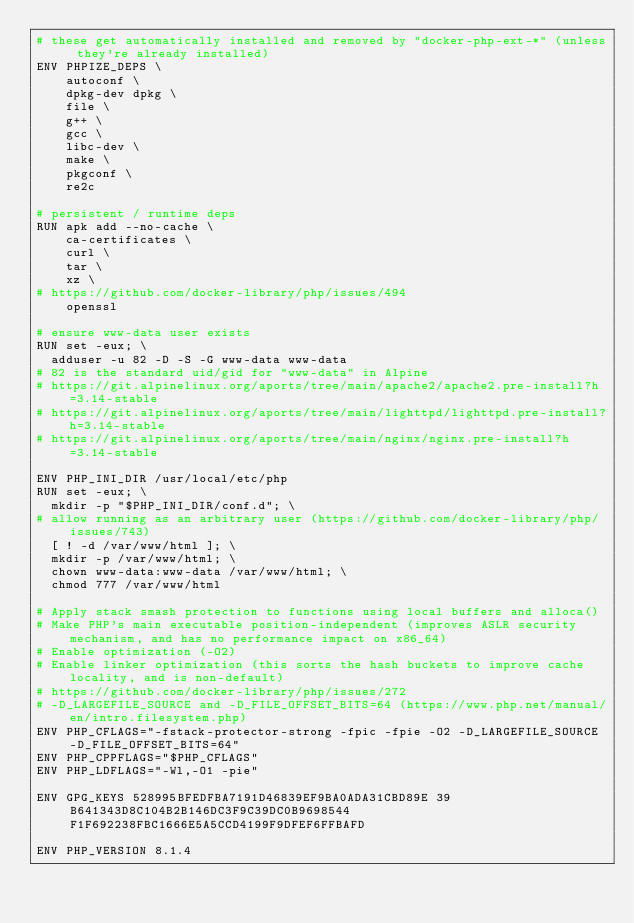Convert code to text. <code><loc_0><loc_0><loc_500><loc_500><_Dockerfile_># these get automatically installed and removed by "docker-php-ext-*" (unless they're already installed)
ENV PHPIZE_DEPS \
		autoconf \
		dpkg-dev dpkg \
		file \
		g++ \
		gcc \
		libc-dev \
		make \
		pkgconf \
		re2c

# persistent / runtime deps
RUN apk add --no-cache \
		ca-certificates \
		curl \
		tar \
		xz \
# https://github.com/docker-library/php/issues/494
		openssl

# ensure www-data user exists
RUN set -eux; \
	adduser -u 82 -D -S -G www-data www-data
# 82 is the standard uid/gid for "www-data" in Alpine
# https://git.alpinelinux.org/aports/tree/main/apache2/apache2.pre-install?h=3.14-stable
# https://git.alpinelinux.org/aports/tree/main/lighttpd/lighttpd.pre-install?h=3.14-stable
# https://git.alpinelinux.org/aports/tree/main/nginx/nginx.pre-install?h=3.14-stable

ENV PHP_INI_DIR /usr/local/etc/php
RUN set -eux; \
	mkdir -p "$PHP_INI_DIR/conf.d"; \
# allow running as an arbitrary user (https://github.com/docker-library/php/issues/743)
	[ ! -d /var/www/html ]; \
	mkdir -p /var/www/html; \
	chown www-data:www-data /var/www/html; \
	chmod 777 /var/www/html

# Apply stack smash protection to functions using local buffers and alloca()
# Make PHP's main executable position-independent (improves ASLR security mechanism, and has no performance impact on x86_64)
# Enable optimization (-O2)
# Enable linker optimization (this sorts the hash buckets to improve cache locality, and is non-default)
# https://github.com/docker-library/php/issues/272
# -D_LARGEFILE_SOURCE and -D_FILE_OFFSET_BITS=64 (https://www.php.net/manual/en/intro.filesystem.php)
ENV PHP_CFLAGS="-fstack-protector-strong -fpic -fpie -O2 -D_LARGEFILE_SOURCE -D_FILE_OFFSET_BITS=64"
ENV PHP_CPPFLAGS="$PHP_CFLAGS"
ENV PHP_LDFLAGS="-Wl,-O1 -pie"

ENV GPG_KEYS 528995BFEDFBA7191D46839EF9BA0ADA31CBD89E 39B641343D8C104B2B146DC3F9C39DC0B9698544 F1F692238FBC1666E5A5CCD4199F9DFEF6FFBAFD

ENV PHP_VERSION 8.1.4</code> 